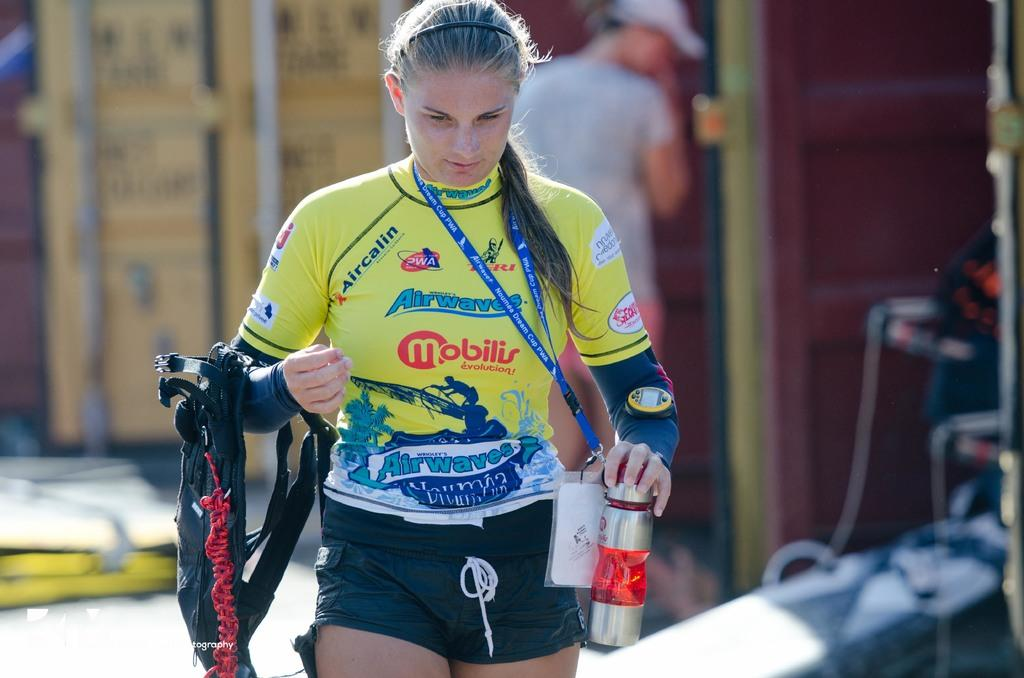<image>
Describe the image concisely. a sports woman in a colorful yellow jersey with words like Mobilis on it 